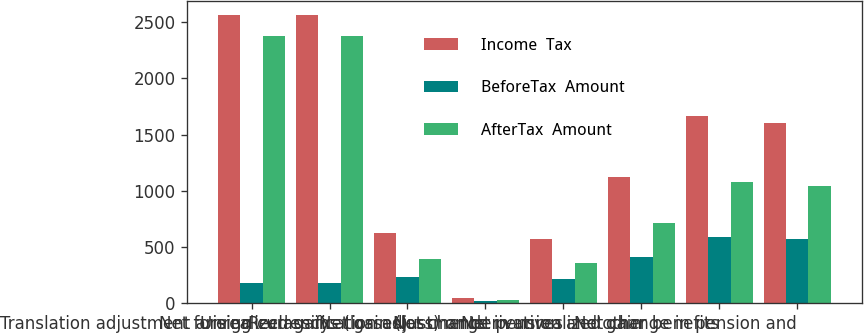Convert chart to OTSL. <chart><loc_0><loc_0><loc_500><loc_500><stacked_bar_chart><ecel><fcel>Translation adjustment arising<fcel>Net foreign currency<fcel>Unrealized gains (losses)<fcel>Reclassification adjustments<fcel>Net gain (loss) on derivatives<fcel>Net change in unrealized gain<fcel>Net pension and other benefits<fcel>Net change in pension and<nl><fcel>Income  Tax<fcel>2560<fcel>2560<fcel>620<fcel>50<fcel>570<fcel>1122<fcel>1666<fcel>1606<nl><fcel>BeforeTax  Amount<fcel>183<fcel>183<fcel>231<fcel>18<fcel>213<fcel>408<fcel>588<fcel>567<nl><fcel>AfterTax  Amount<fcel>2377<fcel>2377<fcel>389<fcel>32<fcel>357<fcel>714<fcel>1078<fcel>1039<nl></chart> 